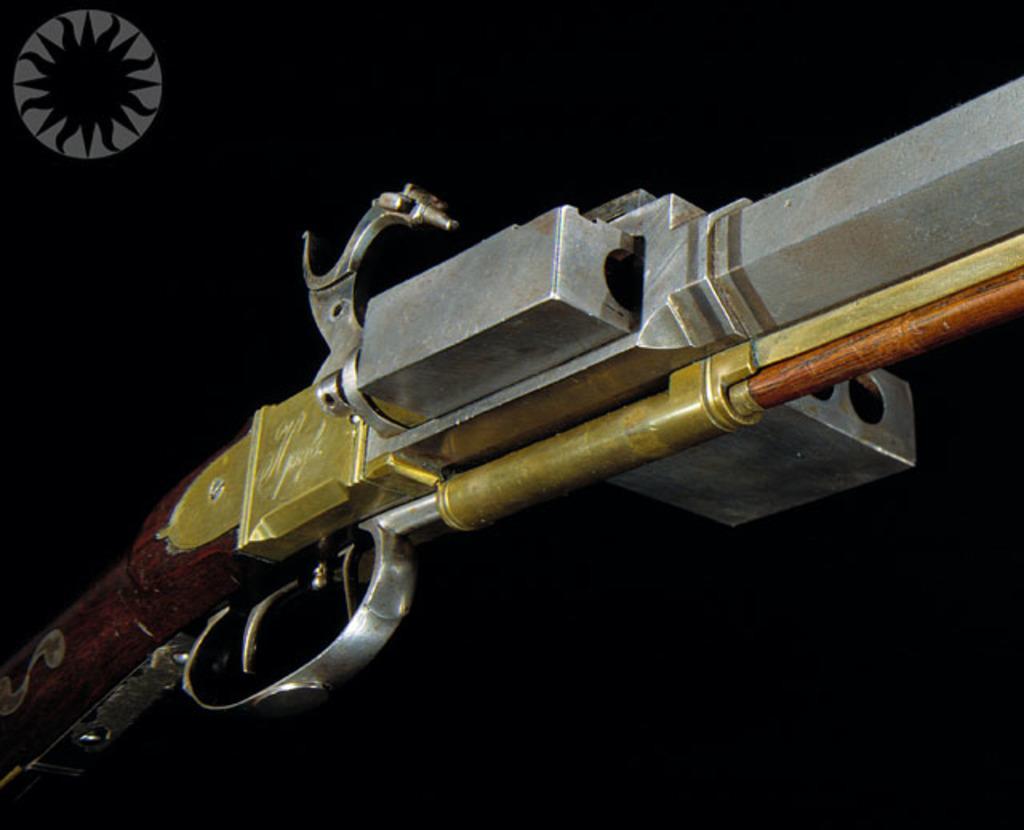In one or two sentences, can you explain what this image depicts? Background portion of the picture is completely dark. In this picture we can see a rifle. 